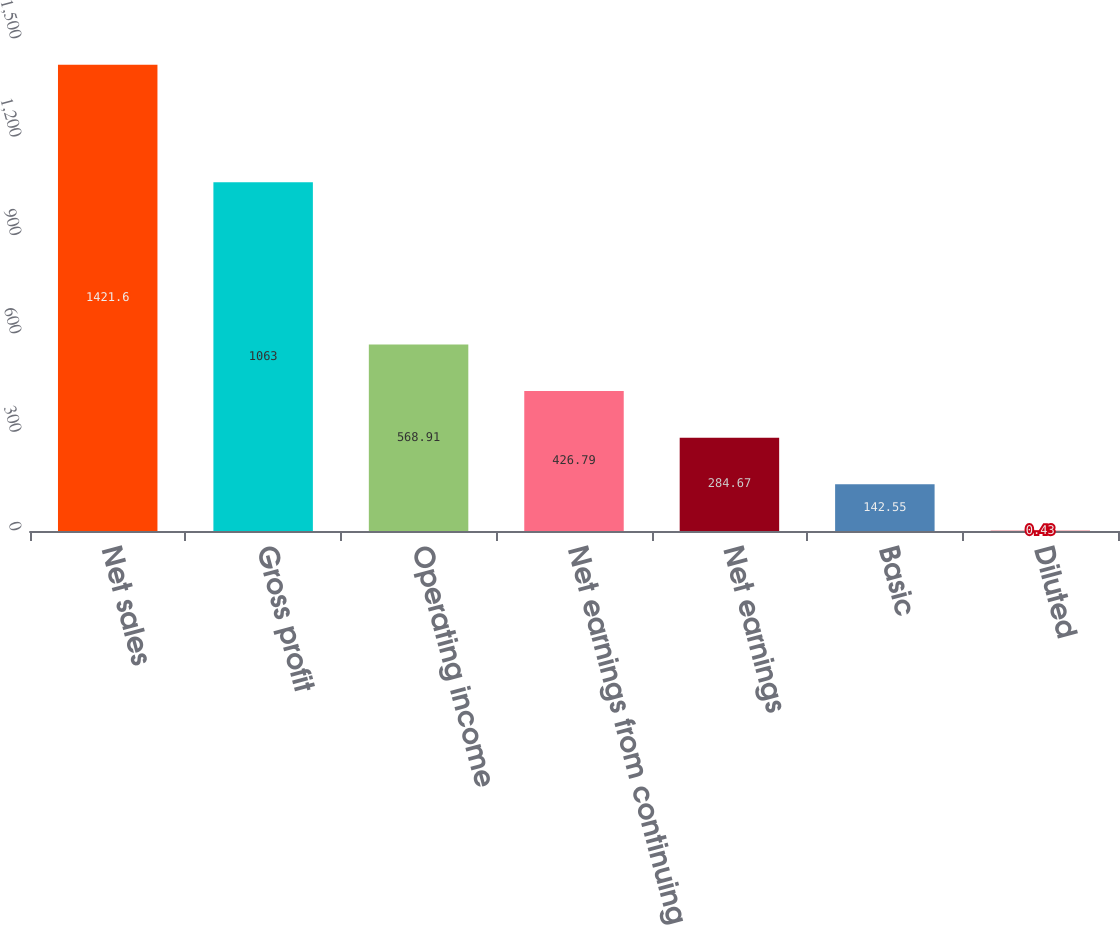Convert chart. <chart><loc_0><loc_0><loc_500><loc_500><bar_chart><fcel>Net sales<fcel>Gross profit<fcel>Operating income<fcel>Net earnings from continuing<fcel>Net earnings<fcel>Basic<fcel>Diluted<nl><fcel>1421.6<fcel>1063<fcel>568.91<fcel>426.79<fcel>284.67<fcel>142.55<fcel>0.43<nl></chart> 